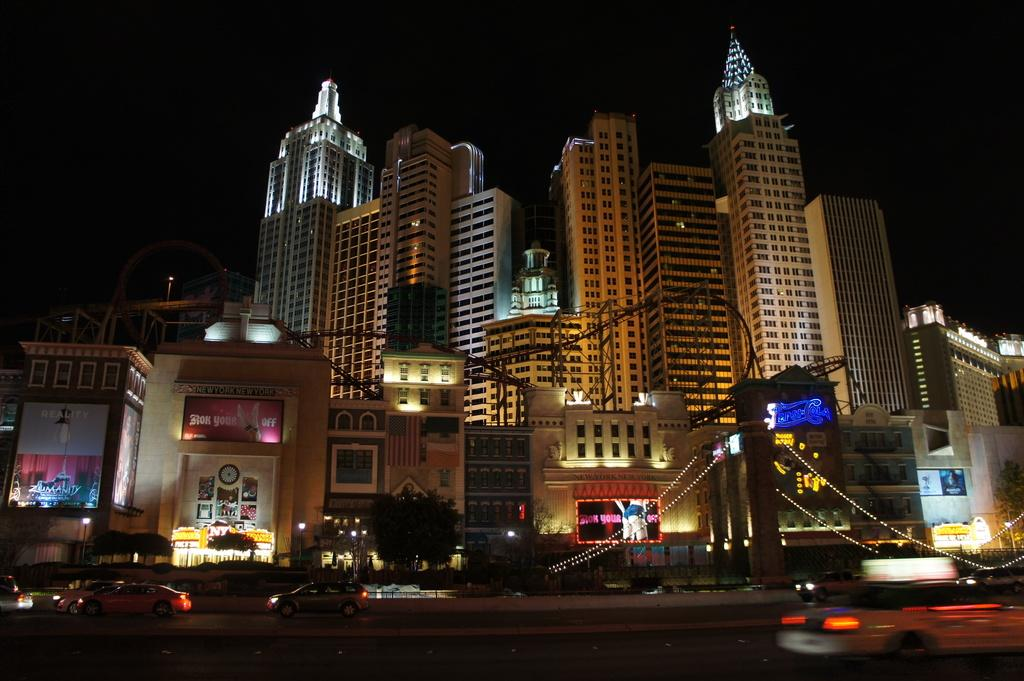What type of buildings are in the center of the image? There are skyscrapers in the center of the image. What can be seen in the front of the image? There are decorative lights in the front of the image. What is visible at the bottom of the image? There is a road visible in the front bottom of the image. What type of vehicles are on the road? Cars are present on the road. Where is the kitten playing with the soap in the image? There is no kitten or soap present in the image. What color is the gold statue in the image? There is no gold statue present in the image. 